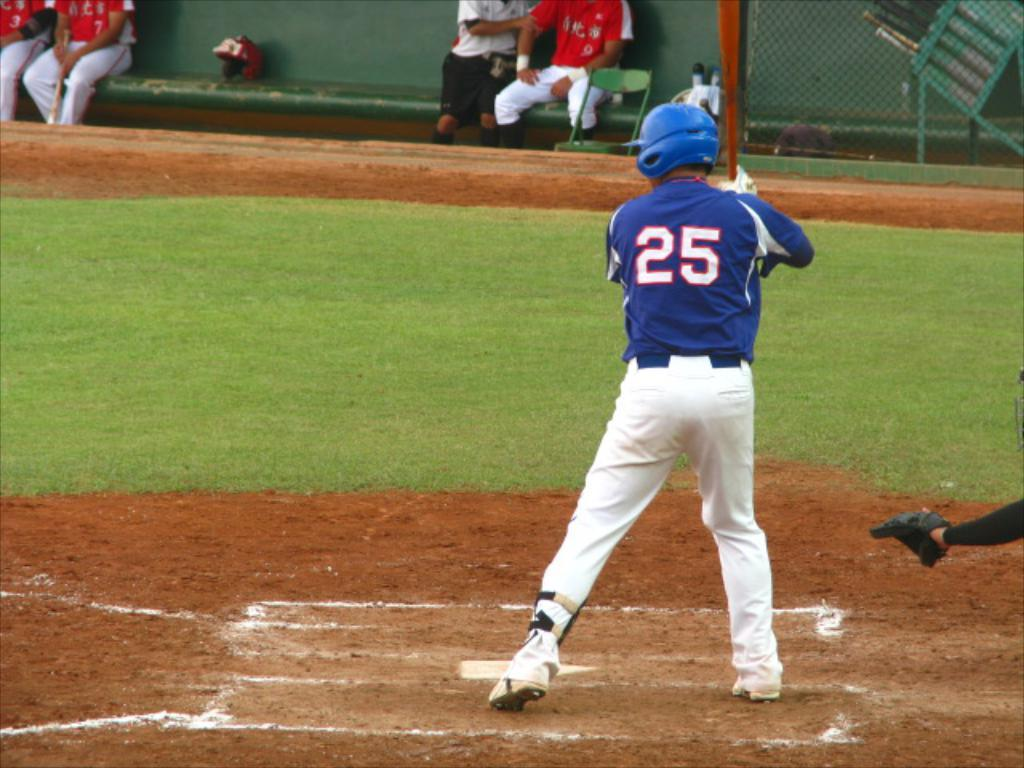<image>
Share a concise interpretation of the image provided. A baseball player holding a bat with number 25 on his jersey. 